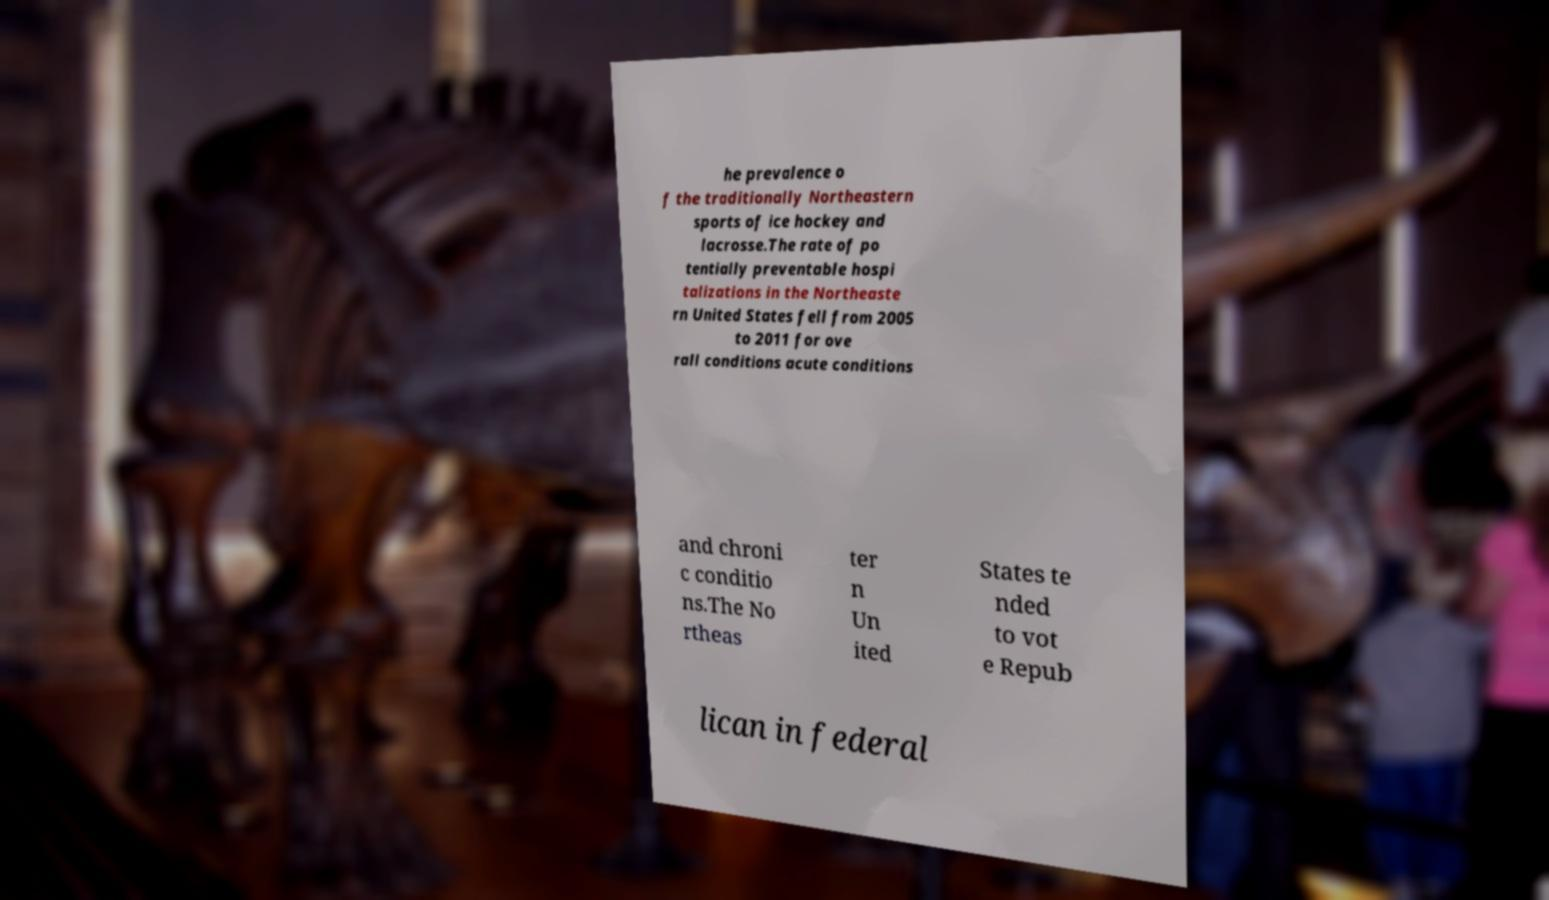Could you extract and type out the text from this image? he prevalence o f the traditionally Northeastern sports of ice hockey and lacrosse.The rate of po tentially preventable hospi talizations in the Northeaste rn United States fell from 2005 to 2011 for ove rall conditions acute conditions and chroni c conditio ns.The No rtheas ter n Un ited States te nded to vot e Repub lican in federal 